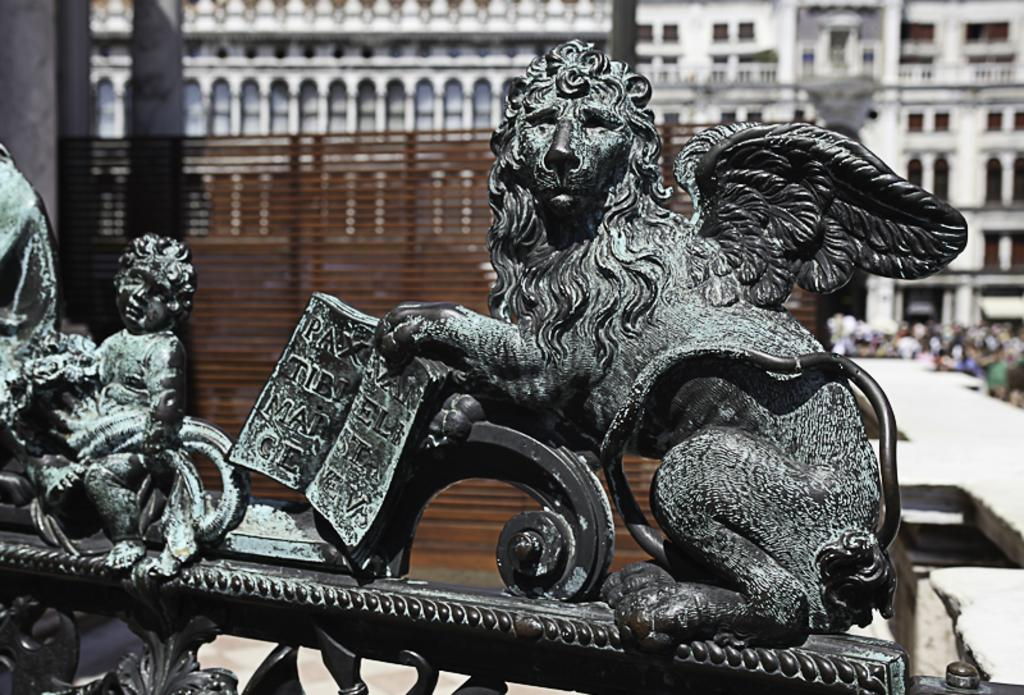What type of art is present in the image? There are sculptures in the image. What can be seen in the distance behind the sculptures? There are buildings in the background of the image. What type of silk is draped over the sculptures in the image? There is no silk present in the image; the sculptures are not draped with any fabric. 